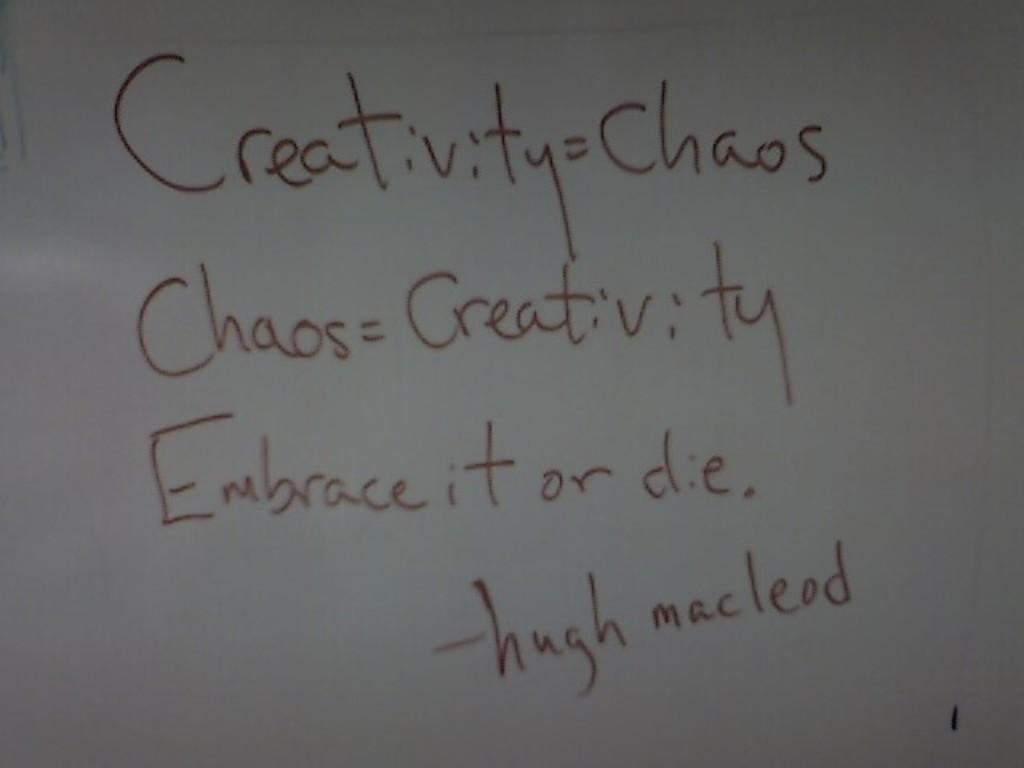<image>
Offer a succinct explanation of the picture presented. A whiteboard with quotes from Hugh Maclead on it 